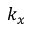<formula> <loc_0><loc_0><loc_500><loc_500>k _ { x }</formula> 